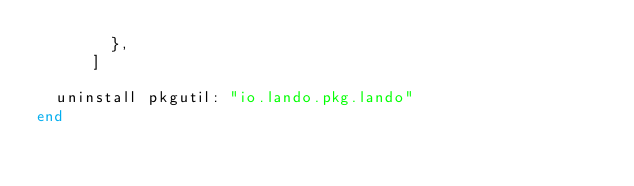Convert code to text. <code><loc_0><loc_0><loc_500><loc_500><_Ruby_>        },
      ]

  uninstall pkgutil: "io.lando.pkg.lando"
end
</code> 